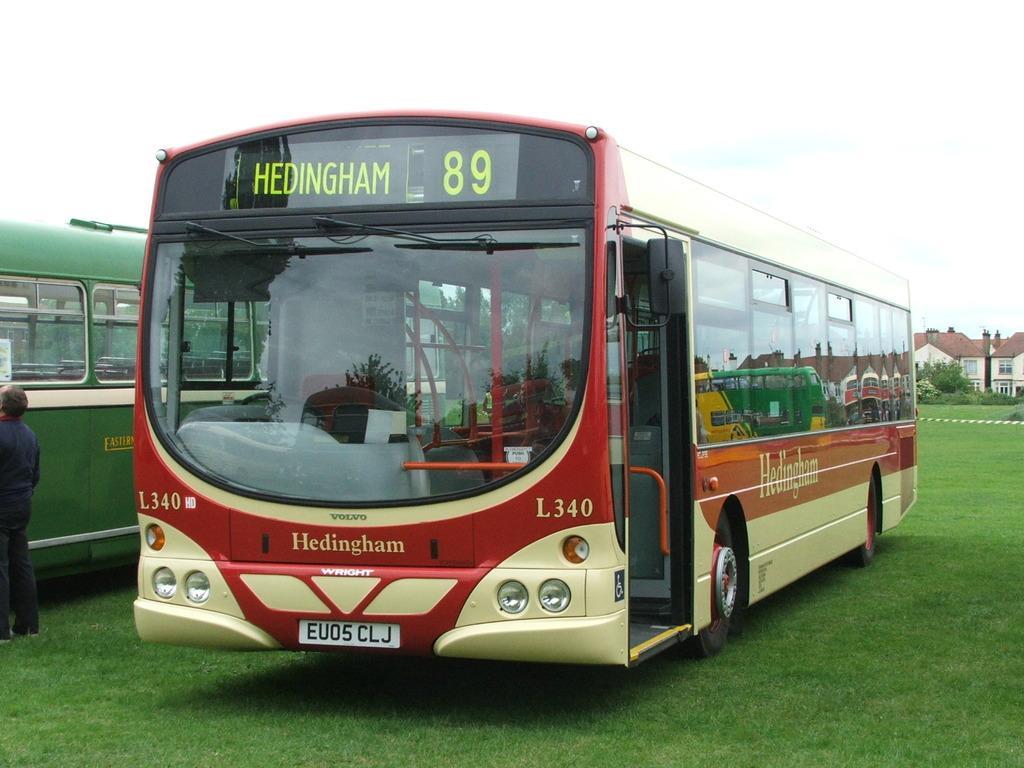In one or two sentences, can you explain what this image depicts? In this picture we can see there are two vehicles parked on the grass. On the left side of the vehicle, a person is standing. Behind the vehicles there are trees, houses and the sky. 